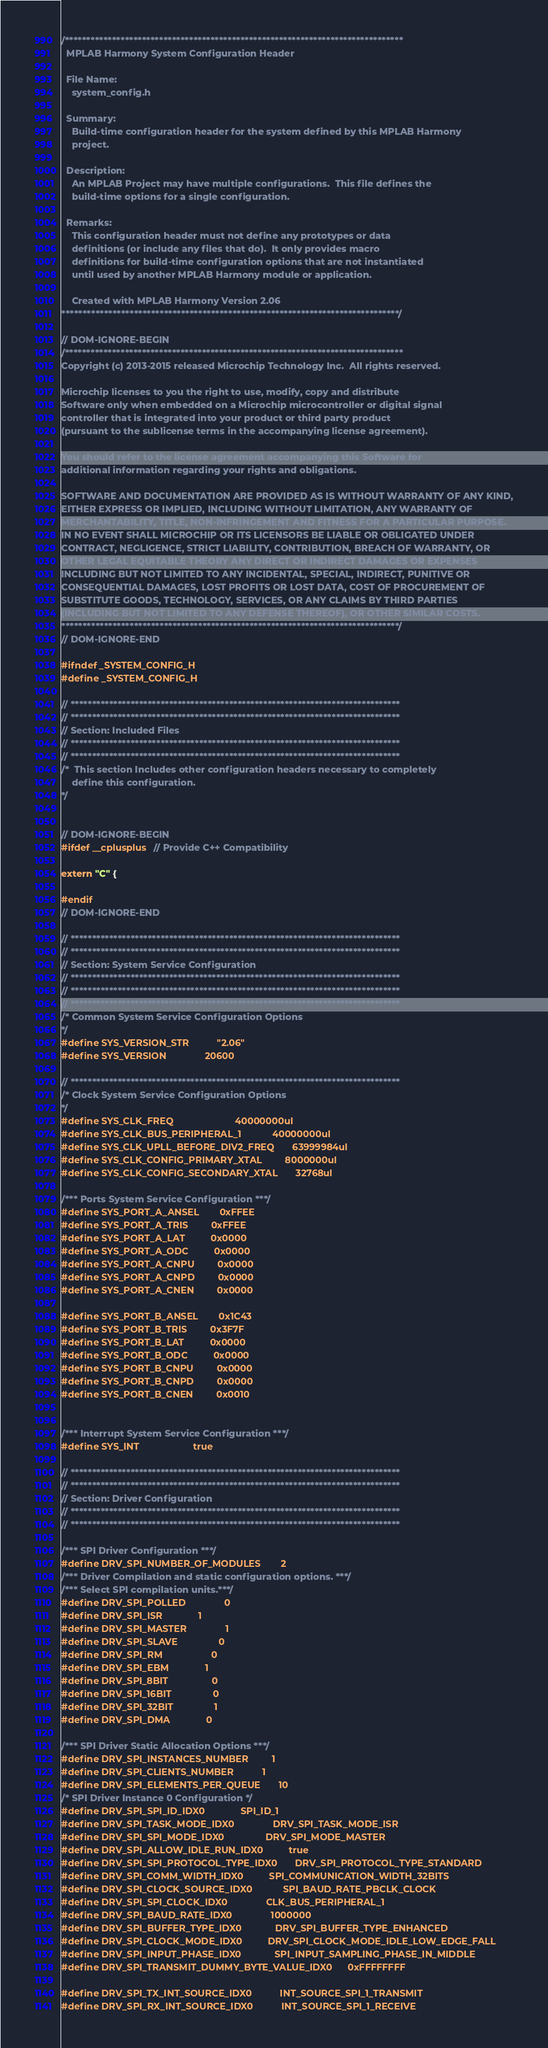<code> <loc_0><loc_0><loc_500><loc_500><_C_>/*******************************************************************************
  MPLAB Harmony System Configuration Header

  File Name:
    system_config.h

  Summary:
    Build-time configuration header for the system defined by this MPLAB Harmony
    project.

  Description:
    An MPLAB Project may have multiple configurations.  This file defines the
    build-time options for a single configuration.

  Remarks:
    This configuration header must not define any prototypes or data
    definitions (or include any files that do).  It only provides macro
    definitions for build-time configuration options that are not instantiated
    until used by another MPLAB Harmony module or application.

    Created with MPLAB Harmony Version 2.06
*******************************************************************************/

// DOM-IGNORE-BEGIN
/*******************************************************************************
Copyright (c) 2013-2015 released Microchip Technology Inc.  All rights reserved.

Microchip licenses to you the right to use, modify, copy and distribute
Software only when embedded on a Microchip microcontroller or digital signal
controller that is integrated into your product or third party product
(pursuant to the sublicense terms in the accompanying license agreement).

You should refer to the license agreement accompanying this Software for
additional information regarding your rights and obligations.

SOFTWARE AND DOCUMENTATION ARE PROVIDED AS IS WITHOUT WARRANTY OF ANY KIND,
EITHER EXPRESS OR IMPLIED, INCLUDING WITHOUT LIMITATION, ANY WARRANTY OF
MERCHANTABILITY, TITLE, NON-INFRINGEMENT AND FITNESS FOR A PARTICULAR PURPOSE.
IN NO EVENT SHALL MICROCHIP OR ITS LICENSORS BE LIABLE OR OBLIGATED UNDER
CONTRACT, NEGLIGENCE, STRICT LIABILITY, CONTRIBUTION, BREACH OF WARRANTY, OR
OTHER LEGAL EQUITABLE THEORY ANY DIRECT OR INDIRECT DAMAGES OR EXPENSES
INCLUDING BUT NOT LIMITED TO ANY INCIDENTAL, SPECIAL, INDIRECT, PUNITIVE OR
CONSEQUENTIAL DAMAGES, LOST PROFITS OR LOST DATA, COST OF PROCUREMENT OF
SUBSTITUTE GOODS, TECHNOLOGY, SERVICES, OR ANY CLAIMS BY THIRD PARTIES
(INCLUDING BUT NOT LIMITED TO ANY DEFENSE THEREOF), OR OTHER SIMILAR COSTS.
*******************************************************************************/
// DOM-IGNORE-END

#ifndef _SYSTEM_CONFIG_H
#define _SYSTEM_CONFIG_H

// *****************************************************************************
// *****************************************************************************
// Section: Included Files
// *****************************************************************************
// *****************************************************************************
/*  This section Includes other configuration headers necessary to completely
    define this configuration.
*/


// DOM-IGNORE-BEGIN
#ifdef __cplusplus  // Provide C++ Compatibility

extern "C" {

#endif
// DOM-IGNORE-END

// *****************************************************************************
// *****************************************************************************
// Section: System Service Configuration
// *****************************************************************************
// *****************************************************************************
// *****************************************************************************
/* Common System Service Configuration Options
*/
#define SYS_VERSION_STR           "2.06"
#define SYS_VERSION               20600

// *****************************************************************************
/* Clock System Service Configuration Options
*/
#define SYS_CLK_FREQ                        40000000ul
#define SYS_CLK_BUS_PERIPHERAL_1            40000000ul
#define SYS_CLK_UPLL_BEFORE_DIV2_FREQ       63999984ul
#define SYS_CLK_CONFIG_PRIMARY_XTAL         8000000ul
#define SYS_CLK_CONFIG_SECONDARY_XTAL       32768ul
   
/*** Ports System Service Configuration ***/
#define SYS_PORT_A_ANSEL        0xFFEE
#define SYS_PORT_A_TRIS         0xFFEE
#define SYS_PORT_A_LAT          0x0000
#define SYS_PORT_A_ODC          0x0000
#define SYS_PORT_A_CNPU         0x0000
#define SYS_PORT_A_CNPD         0x0000
#define SYS_PORT_A_CNEN         0x0000

#define SYS_PORT_B_ANSEL        0x1C43
#define SYS_PORT_B_TRIS         0x3F7F
#define SYS_PORT_B_LAT          0x0000
#define SYS_PORT_B_ODC          0x0000
#define SYS_PORT_B_CNPU         0x0000
#define SYS_PORT_B_CNPD         0x0000
#define SYS_PORT_B_CNEN         0x0010


/*** Interrupt System Service Configuration ***/
#define SYS_INT                     true

// *****************************************************************************
// *****************************************************************************
// Section: Driver Configuration
// *****************************************************************************
// *****************************************************************************

/*** SPI Driver Configuration ***/
#define DRV_SPI_NUMBER_OF_MODULES		2
/*** Driver Compilation and static configuration options. ***/
/*** Select SPI compilation units.***/
#define DRV_SPI_POLLED 				0
#define DRV_SPI_ISR 				1
#define DRV_SPI_MASTER 				1
#define DRV_SPI_SLAVE 				0
#define DRV_SPI_RM 					0
#define DRV_SPI_EBM 				1
#define DRV_SPI_8BIT 				0
#define DRV_SPI_16BIT 				0
#define DRV_SPI_32BIT 				1
#define DRV_SPI_DMA 				0

/*** SPI Driver Static Allocation Options ***/
#define DRV_SPI_INSTANCES_NUMBER 		1
#define DRV_SPI_CLIENTS_NUMBER 			1
#define DRV_SPI_ELEMENTS_PER_QUEUE 		10
/* SPI Driver Instance 0 Configuration */
#define DRV_SPI_SPI_ID_IDX0 				SPI_ID_1
#define DRV_SPI_TASK_MODE_IDX0 				DRV_SPI_TASK_MODE_ISR
#define DRV_SPI_SPI_MODE_IDX0				DRV_SPI_MODE_MASTER
#define DRV_SPI_ALLOW_IDLE_RUN_IDX0			true
#define DRV_SPI_SPI_PROTOCOL_TYPE_IDX0 		DRV_SPI_PROTOCOL_TYPE_STANDARD
#define DRV_SPI_COMM_WIDTH_IDX0 			SPI_COMMUNICATION_WIDTH_32BITS
#define DRV_SPI_CLOCK_SOURCE_IDX0 		    SPI_BAUD_RATE_PBCLK_CLOCK
#define DRV_SPI_SPI_CLOCK_IDX0 				CLK_BUS_PERIPHERAL_1
#define DRV_SPI_BAUD_RATE_IDX0 				1000000
#define DRV_SPI_BUFFER_TYPE_IDX0 			DRV_SPI_BUFFER_TYPE_ENHANCED
#define DRV_SPI_CLOCK_MODE_IDX0 			DRV_SPI_CLOCK_MODE_IDLE_LOW_EDGE_FALL
#define DRV_SPI_INPUT_PHASE_IDX0 			SPI_INPUT_SAMPLING_PHASE_IN_MIDDLE
#define DRV_SPI_TRANSMIT_DUMMY_BYTE_VALUE_IDX0      0xFFFFFFFF

#define DRV_SPI_TX_INT_SOURCE_IDX0 			INT_SOURCE_SPI_1_TRANSMIT
#define DRV_SPI_RX_INT_SOURCE_IDX0 			INT_SOURCE_SPI_1_RECEIVE</code> 